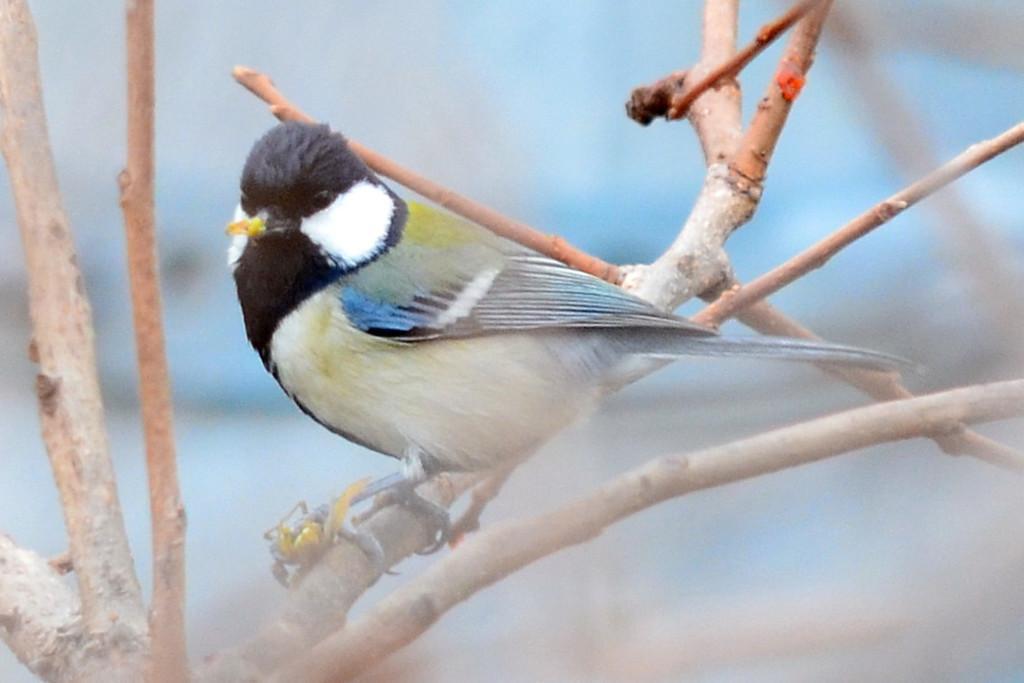In one or two sentences, can you explain what this image depicts? In this image we can see a bird. We can also see the stems and the background is blurred. 